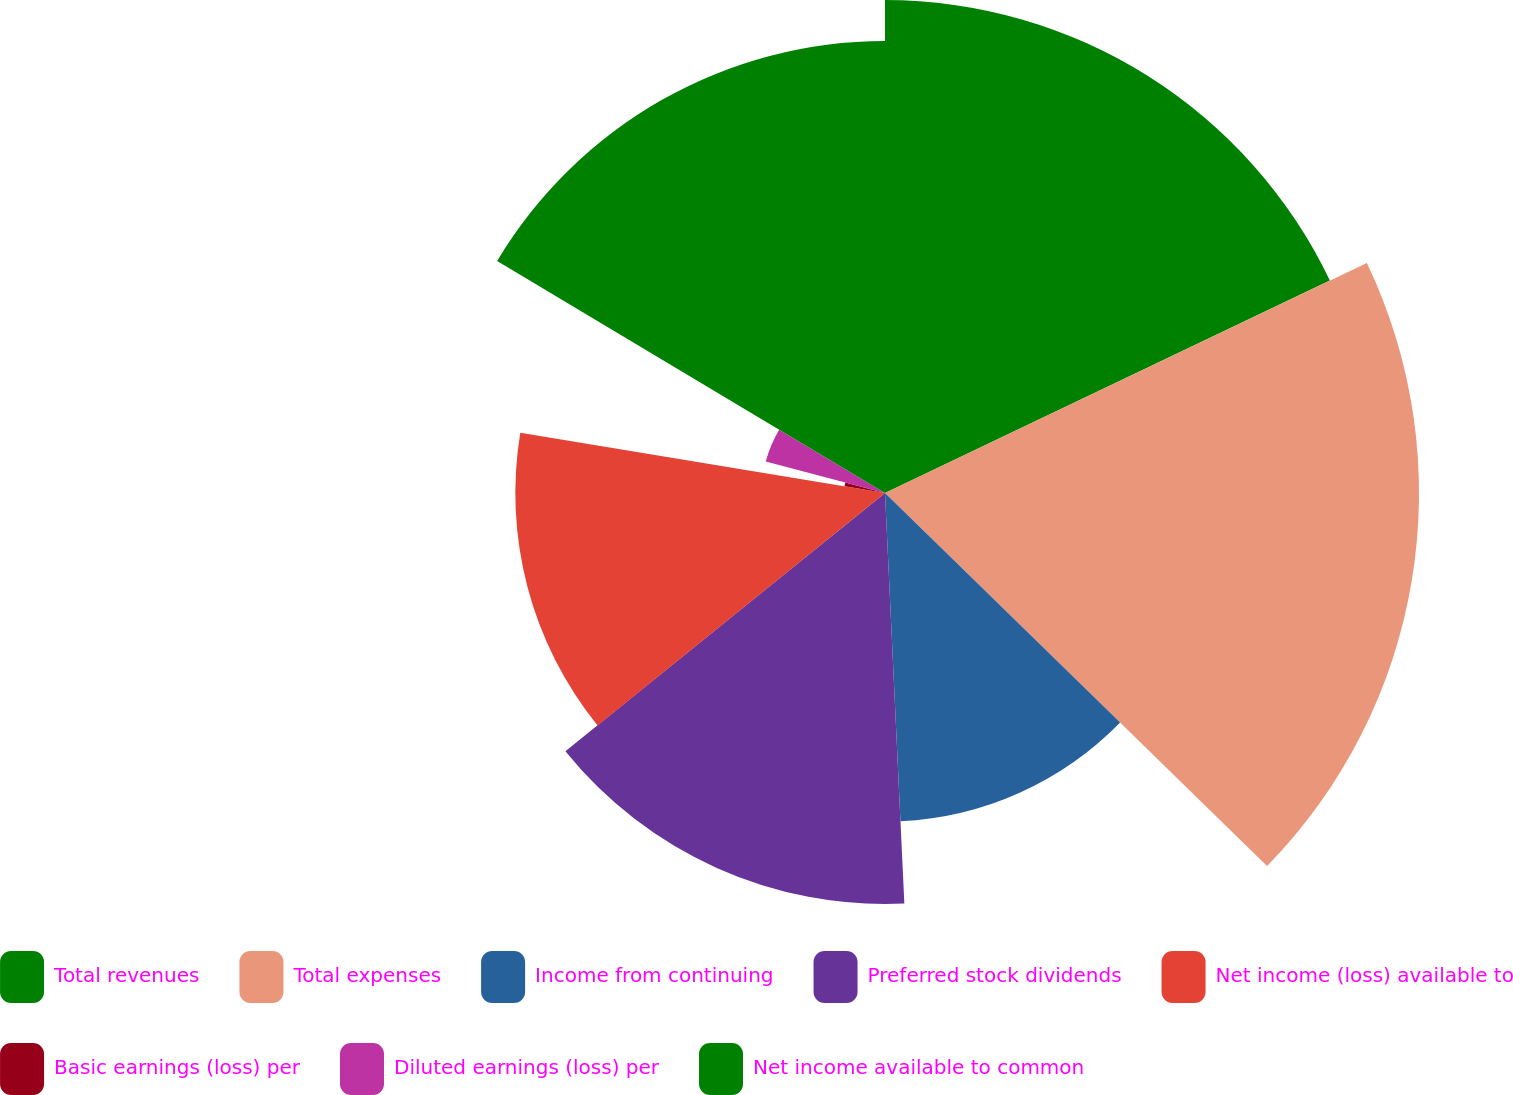<chart> <loc_0><loc_0><loc_500><loc_500><pie_chart><fcel>Total revenues<fcel>Total expenses<fcel>Income from continuing<fcel>Preferred stock dividends<fcel>Net income (loss) available to<fcel>Basic earnings (loss) per<fcel>Diluted earnings (loss) per<fcel>Net income available to common<nl><fcel>17.91%<fcel>19.4%<fcel>11.94%<fcel>14.93%<fcel>13.43%<fcel>1.49%<fcel>4.48%<fcel>16.42%<nl></chart> 